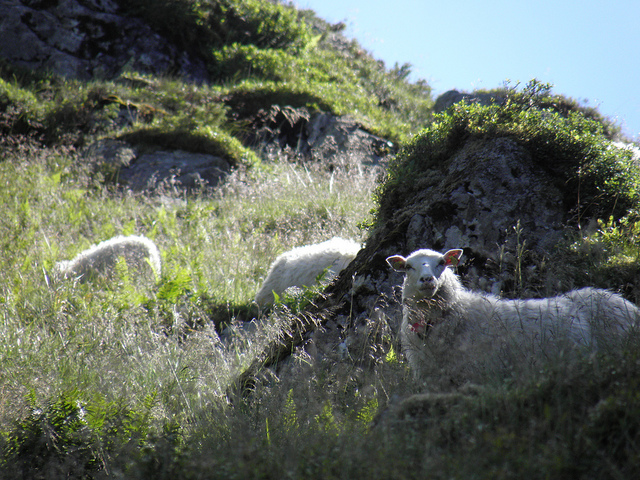<image>Which lamb is on the rock? I don't know which lamb is on the rock. There might not be any. Which lamb is on the rock? I am not sure which lamb is on the rock. There are no visible lambs on the rock. 